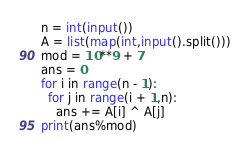Convert code to text. <code><loc_0><loc_0><loc_500><loc_500><_Python_>n = int(input())
A = list(map(int,input().split()))
mod = 10**9 + 7
ans = 0
for i in range(n - 1):
  for j in range(i + 1,n):
    ans += A[i] ^ A[j]
print(ans%mod)</code> 